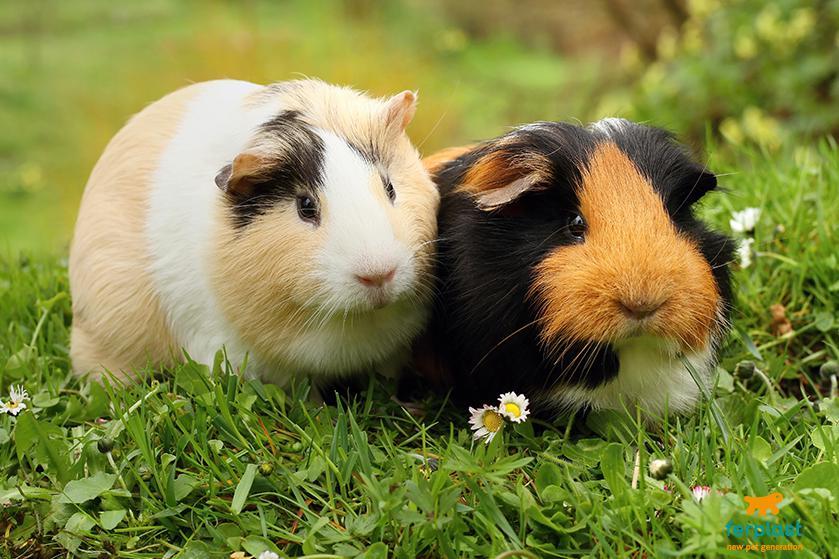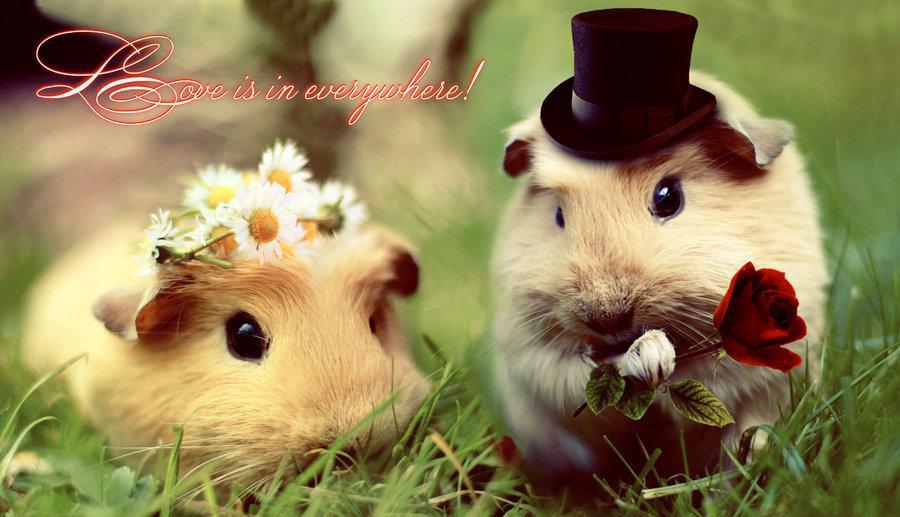The first image is the image on the left, the second image is the image on the right. Evaluate the accuracy of this statement regarding the images: "The right image contains exactly one rodent.". Is it true? Answer yes or no. No. The first image is the image on the left, the second image is the image on the right. Analyze the images presented: Is the assertion "Each image shows two side-by-side guinea pigs." valid? Answer yes or no. Yes. 